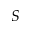<formula> <loc_0><loc_0><loc_500><loc_500>S</formula> 